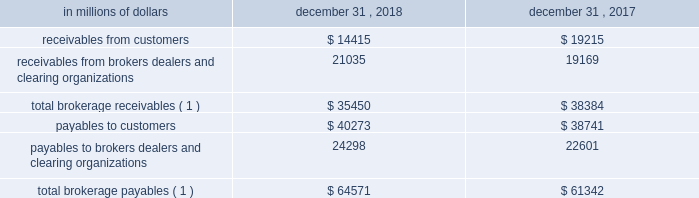12 .
Brokerage receivables and brokerage payables the company has receivables and payables for financial instruments sold to and purchased from brokers , dealers and customers , which arise in the ordinary course of business .
Citi is exposed to risk of loss from the inability of brokers , dealers or customers to pay for purchases or to deliver the financial instruments sold , in which case citi would have to sell or purchase the financial instruments at prevailing market prices .
Credit risk is reduced to the extent that an exchange or clearing organization acts as a counterparty to the transaction and replaces the broker , dealer or customer in question .
Citi seeks to protect itself from the risks associated with customer activities by requiring customers to maintain margin collateral in compliance with regulatory and internal guidelines .
Margin levels are monitored daily , and customers deposit additional collateral as required .
Where customers cannot meet collateral requirements , citi may liquidate sufficient underlying financial instruments to bring the customer into compliance with the required margin level .
Exposure to credit risk is impacted by market volatility , which may impair the ability of clients to satisfy their obligations to citi .
Credit limits are established and closely monitored for customers and for brokers and dealers engaged in forwards , futures and other transactions deemed to be credit sensitive .
Brokerage receivables and brokerage payables consisted of the following: .
Total brokerage payables ( 1 ) $ 64571 $ 61342 ( 1 ) includes brokerage receivables and payables recorded by citi broker-dealer entities that are accounted for in accordance with the aicpa accounting guide for brokers and dealers in securities as codified in asc 940-320. .
What percentage of total brokerage payables at december 31 , 2017 where receivables from customers? 
Computations: (19215 / 61342)
Answer: 0.31324. 